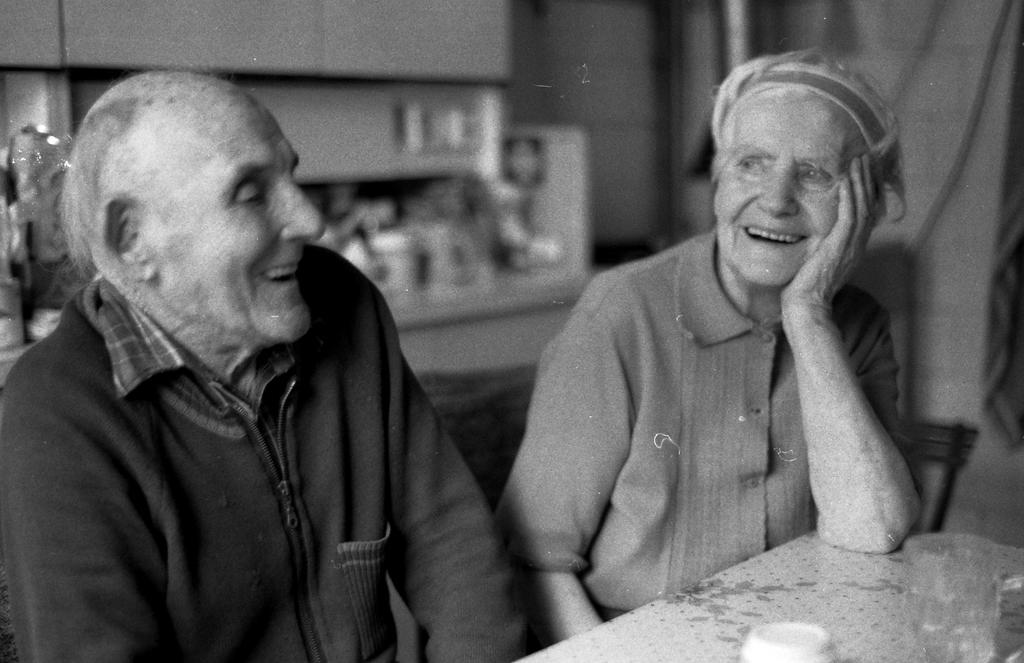How many people are in the image? There are two persons in the image. What are the two persons doing in the image? The two persons are sitting on a table. What objects are on the table with the two persons? There are glasses on the table. What can be seen in the background of the image? There are utensils arranged in shelves in the background of the image. What is the tendency of the beam in the image? There is no beam present in the image. What type of voyage is depicted in the image? There is no voyage depicted in the image; it features two persons sitting on a table with glasses and a background of utensils arranged in shelves. 